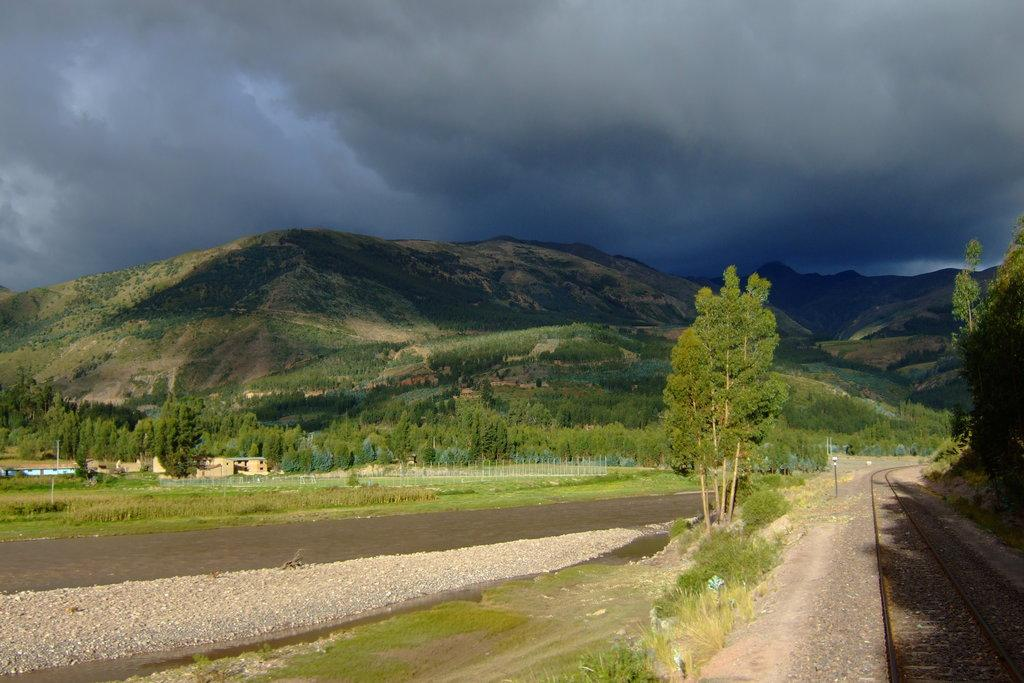What type of natural formation can be seen in the image? There are mountains in the image. What type of vegetation is present in the image? There are trees and plants in the image. What man-made structure can be seen in the image? There is a railway track in the image. What type of buildings are visible in the image? There are houses in the image. What type of jelly can be seen on the railway track in the image? There is no jelly present on the railway track or anywhere else in the image. How many balls are visible in the image? There are no balls visible in the image. 